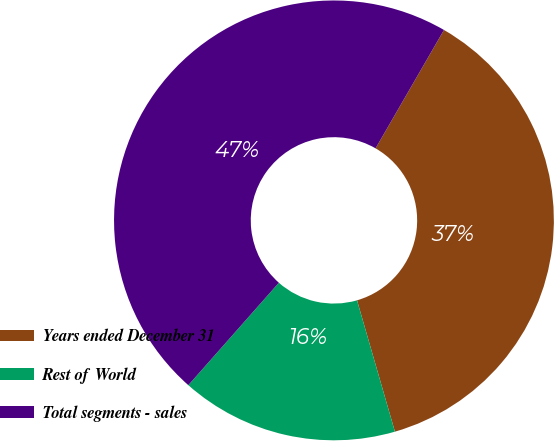Convert chart. <chart><loc_0><loc_0><loc_500><loc_500><pie_chart><fcel>Years ended December 31<fcel>Rest of World<fcel>Total segments - sales<nl><fcel>37.19%<fcel>15.99%<fcel>46.82%<nl></chart> 